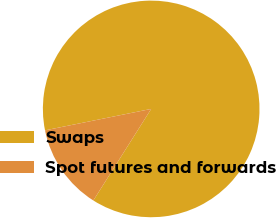Convert chart. <chart><loc_0><loc_0><loc_500><loc_500><pie_chart><fcel>Swaps<fcel>Spot futures and forwards<nl><fcel>87.14%<fcel>12.86%<nl></chart> 